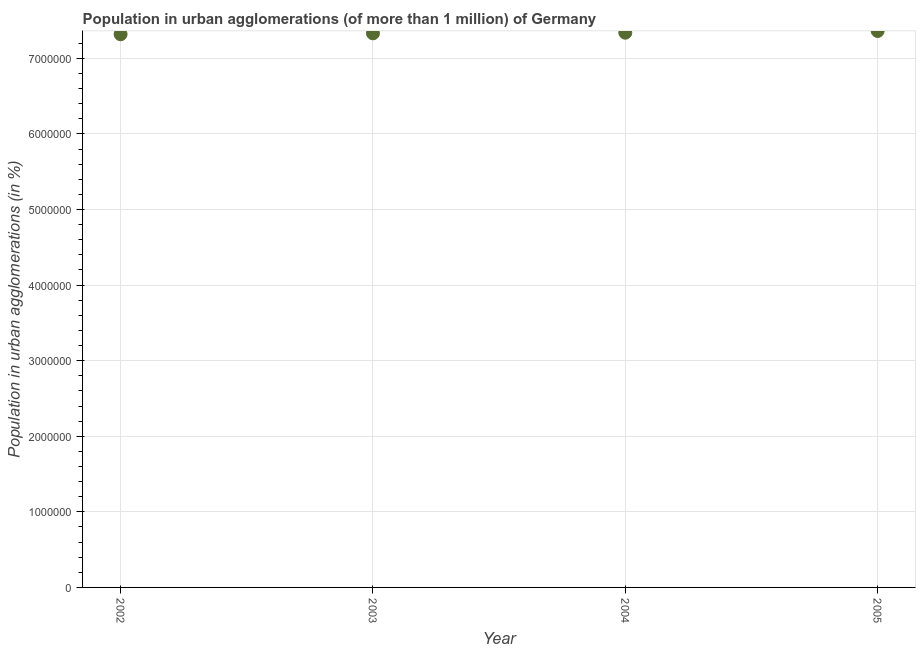What is the population in urban agglomerations in 2005?
Offer a very short reply. 7.36e+06. Across all years, what is the maximum population in urban agglomerations?
Ensure brevity in your answer.  7.36e+06. Across all years, what is the minimum population in urban agglomerations?
Give a very brief answer. 7.32e+06. In which year was the population in urban agglomerations minimum?
Your answer should be very brief. 2002. What is the sum of the population in urban agglomerations?
Your response must be concise. 2.93e+07. What is the difference between the population in urban agglomerations in 2003 and 2004?
Offer a terse response. -8525. What is the average population in urban agglomerations per year?
Ensure brevity in your answer.  7.34e+06. What is the median population in urban agglomerations?
Offer a terse response. 7.33e+06. In how many years, is the population in urban agglomerations greater than 4400000 %?
Offer a very short reply. 4. What is the ratio of the population in urban agglomerations in 2002 to that in 2004?
Offer a terse response. 1. Is the population in urban agglomerations in 2002 less than that in 2003?
Your answer should be compact. Yes. What is the difference between the highest and the second highest population in urban agglomerations?
Ensure brevity in your answer.  2.26e+04. What is the difference between the highest and the lowest population in urban agglomerations?
Offer a terse response. 4.33e+04. In how many years, is the population in urban agglomerations greater than the average population in urban agglomerations taken over all years?
Provide a succinct answer. 2. Does the population in urban agglomerations monotonically increase over the years?
Provide a short and direct response. Yes. How many years are there in the graph?
Make the answer very short. 4. What is the difference between two consecutive major ticks on the Y-axis?
Offer a terse response. 1.00e+06. What is the title of the graph?
Your answer should be very brief. Population in urban agglomerations (of more than 1 million) of Germany. What is the label or title of the X-axis?
Give a very brief answer. Year. What is the label or title of the Y-axis?
Offer a very short reply. Population in urban agglomerations (in %). What is the Population in urban agglomerations (in %) in 2002?
Ensure brevity in your answer.  7.32e+06. What is the Population in urban agglomerations (in %) in 2003?
Offer a very short reply. 7.33e+06. What is the Population in urban agglomerations (in %) in 2004?
Make the answer very short. 7.34e+06. What is the Population in urban agglomerations (in %) in 2005?
Keep it short and to the point. 7.36e+06. What is the difference between the Population in urban agglomerations (in %) in 2002 and 2003?
Provide a short and direct response. -1.22e+04. What is the difference between the Population in urban agglomerations (in %) in 2002 and 2004?
Ensure brevity in your answer.  -2.07e+04. What is the difference between the Population in urban agglomerations (in %) in 2002 and 2005?
Give a very brief answer. -4.33e+04. What is the difference between the Population in urban agglomerations (in %) in 2003 and 2004?
Make the answer very short. -8525. What is the difference between the Population in urban agglomerations (in %) in 2003 and 2005?
Provide a succinct answer. -3.12e+04. What is the difference between the Population in urban agglomerations (in %) in 2004 and 2005?
Offer a very short reply. -2.26e+04. What is the ratio of the Population in urban agglomerations (in %) in 2002 to that in 2004?
Give a very brief answer. 1. What is the ratio of the Population in urban agglomerations (in %) in 2002 to that in 2005?
Keep it short and to the point. 0.99. What is the ratio of the Population in urban agglomerations (in %) in 2003 to that in 2004?
Ensure brevity in your answer.  1. 